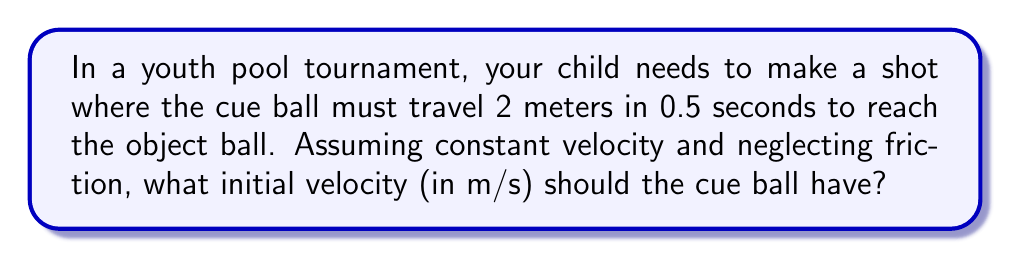Help me with this question. Let's approach this step-by-step using the basic equation for constant velocity:

1) The equation relating distance (d), velocity (v), and time (t) is:
   $$d = vt$$

2) We are given:
   - Distance (d) = 2 meters
   - Time (t) = 0.5 seconds

3) Substituting these values into the equation:
   $$2 = v \cdot 0.5$$

4) To solve for v, we divide both sides by 0.5:
   $$\frac{2}{0.5} = v$$

5) Simplify:
   $$4 = v$$

Therefore, the cue ball needs an initial velocity of 4 m/s to travel 2 meters in 0.5 seconds.
Answer: 4 m/s 